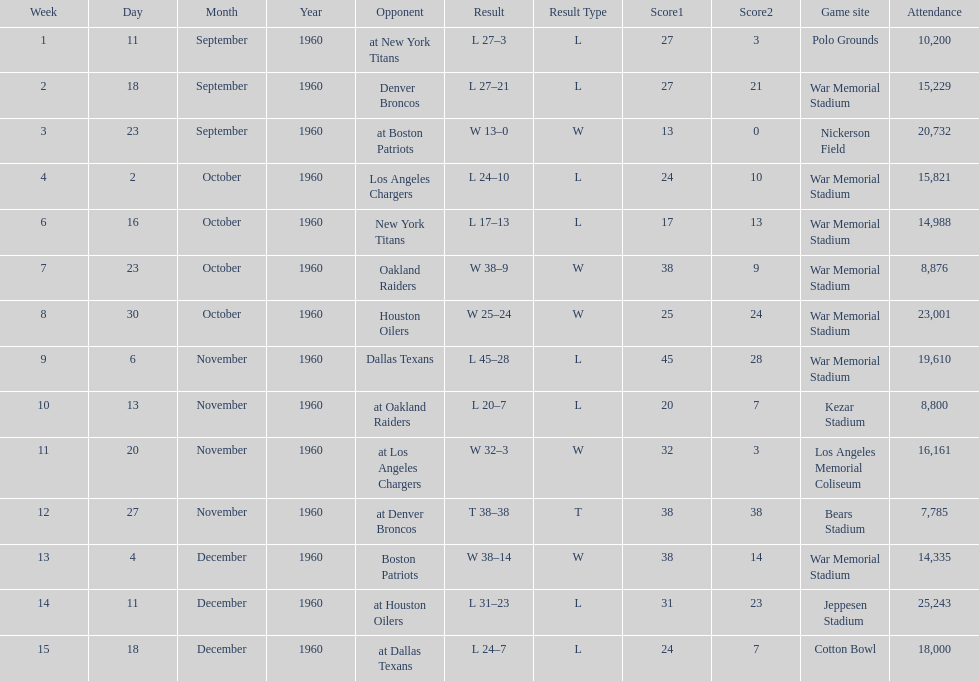Who was the only opponent they played which resulted in a tie game? Denver Broncos. 